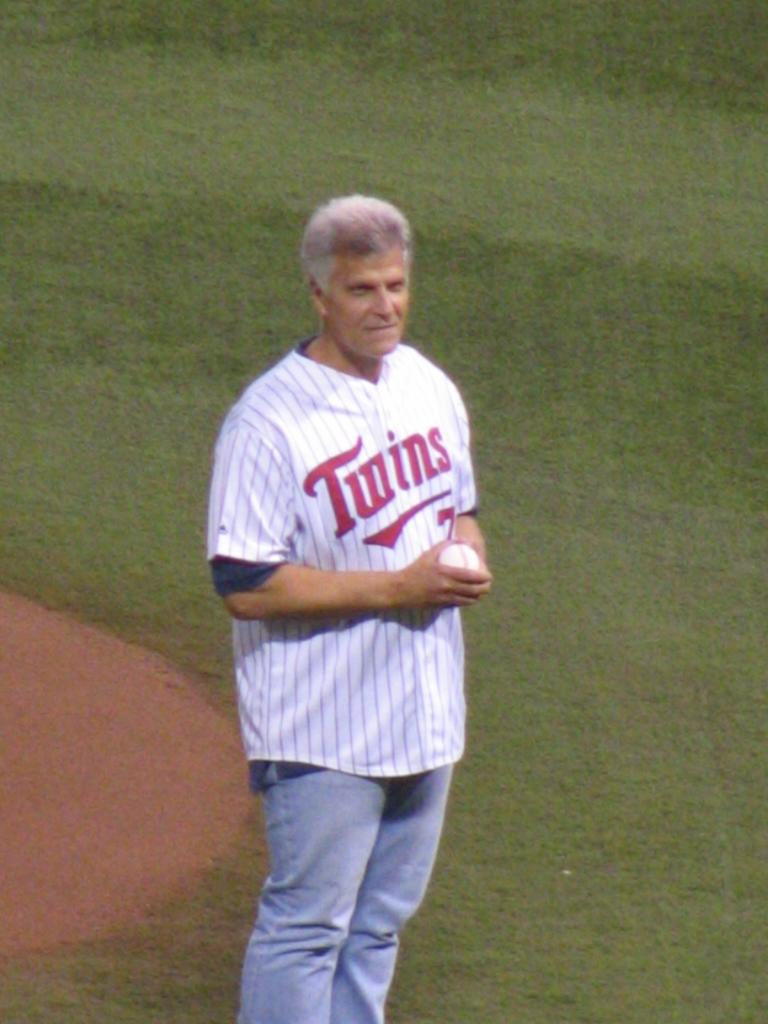Is that a ball on hishands?
Make the answer very short. Yes. 